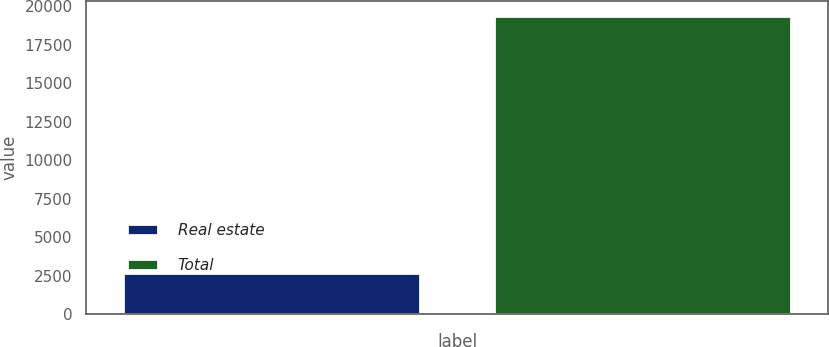Convert chart. <chart><loc_0><loc_0><loc_500><loc_500><bar_chart><fcel>Real estate<fcel>Total<nl><fcel>2659<fcel>19399<nl></chart> 